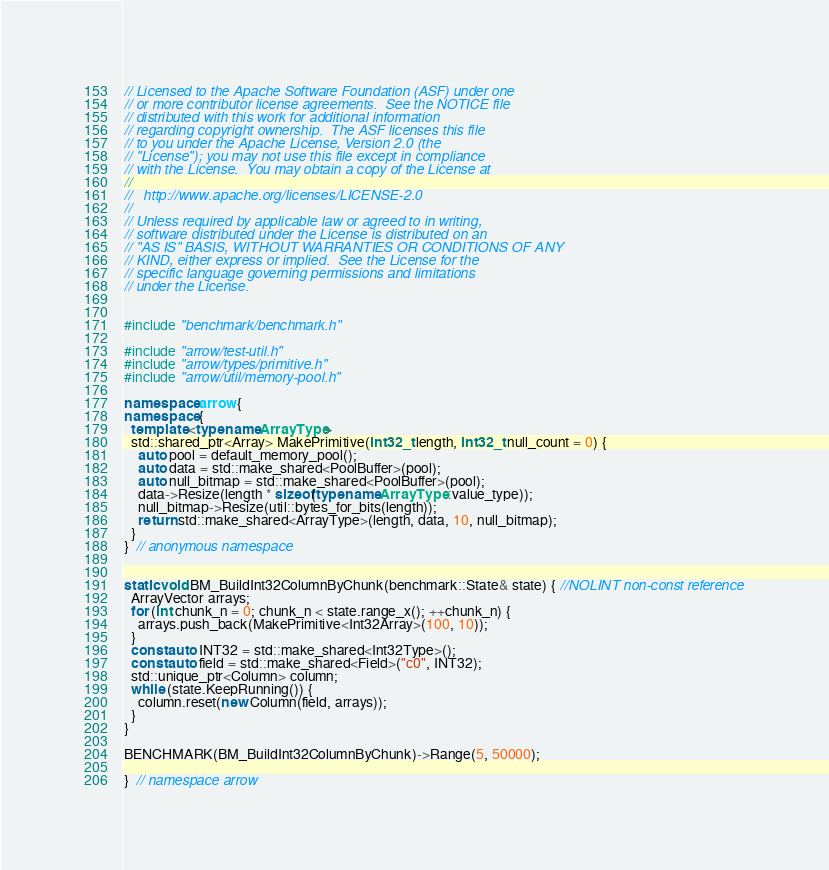<code> <loc_0><loc_0><loc_500><loc_500><_C++_>// Licensed to the Apache Software Foundation (ASF) under one
// or more contributor license agreements.  See the NOTICE file
// distributed with this work for additional information
// regarding copyright ownership.  The ASF licenses this file
// to you under the Apache License, Version 2.0 (the
// "License"); you may not use this file except in compliance
// with the License.  You may obtain a copy of the License at
//
//   http://www.apache.org/licenses/LICENSE-2.0
//
// Unless required by applicable law or agreed to in writing,
// software distributed under the License is distributed on an
// "AS IS" BASIS, WITHOUT WARRANTIES OR CONDITIONS OF ANY
// KIND, either express or implied.  See the License for the
// specific language governing permissions and limitations
// under the License.


#include "benchmark/benchmark.h"

#include "arrow/test-util.h"
#include "arrow/types/primitive.h"
#include "arrow/util/memory-pool.h"

namespace arrow {
namespace {
  template <typename ArrayType>
  std::shared_ptr<Array> MakePrimitive(int32_t length, int32_t null_count = 0) {
    auto pool = default_memory_pool();
    auto data = std::make_shared<PoolBuffer>(pool);
    auto null_bitmap = std::make_shared<PoolBuffer>(pool);
    data->Resize(length * sizeof(typename ArrayType::value_type));
    null_bitmap->Resize(util::bytes_for_bits(length));
    return std::make_shared<ArrayType>(length, data, 10, null_bitmap);
  }
}  // anonymous namespace


static void BM_BuildInt32ColumnByChunk(benchmark::State& state) { //NOLINT non-const reference
  ArrayVector arrays;
  for (int chunk_n = 0; chunk_n < state.range_x(); ++chunk_n) {
    arrays.push_back(MakePrimitive<Int32Array>(100, 10));
  }
  const auto INT32 = std::make_shared<Int32Type>();
  const auto field = std::make_shared<Field>("c0", INT32);
  std::unique_ptr<Column> column;
  while (state.KeepRunning()) {
    column.reset(new Column(field, arrays));
  }
}

BENCHMARK(BM_BuildInt32ColumnByChunk)->Range(5, 50000);

}  // namespace arrow
</code> 